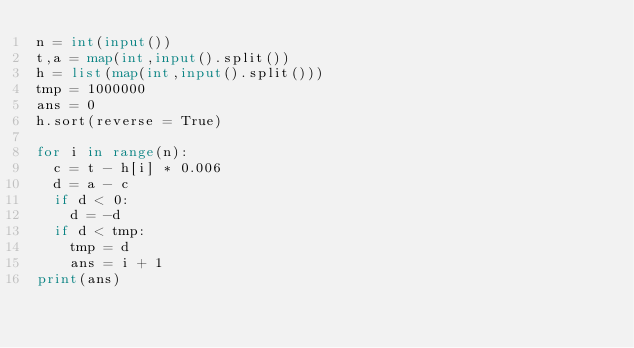<code> <loc_0><loc_0><loc_500><loc_500><_Python_>n = int(input())
t,a = map(int,input().split())
h = list(map(int,input().split()))
tmp = 1000000
ans = 0
h.sort(reverse = True)

for i in range(n):
  c = t - h[i] * 0.006
  d = a - c
  if d < 0:
    d = -d
  if d < tmp:
    tmp = d
    ans = i + 1
print(ans)</code> 